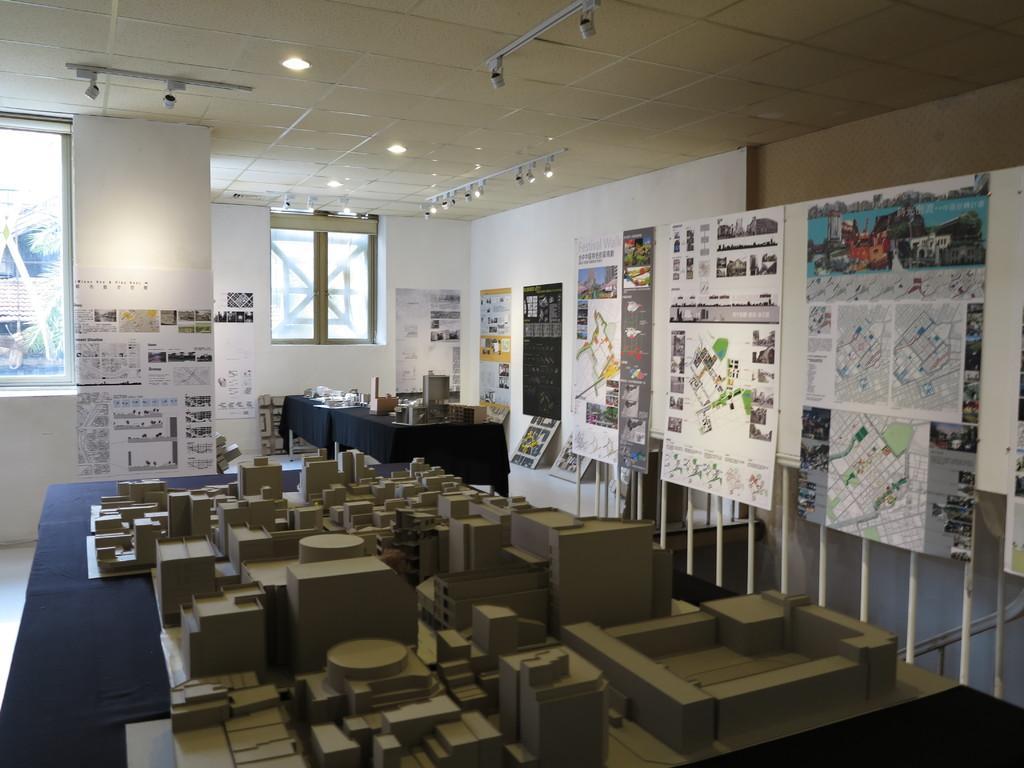In one or two sentences, can you explain what this image depicts? In this image, we can see architectures on the table and in the background, there are posters, boards and some papers are on the wall and we can see some other objects on the stands. At the top, there are lights and we can see rods and there is a window. 